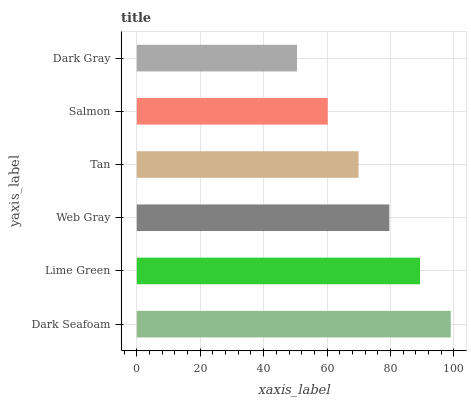Is Dark Gray the minimum?
Answer yes or no. Yes. Is Dark Seafoam the maximum?
Answer yes or no. Yes. Is Lime Green the minimum?
Answer yes or no. No. Is Lime Green the maximum?
Answer yes or no. No. Is Dark Seafoam greater than Lime Green?
Answer yes or no. Yes. Is Lime Green less than Dark Seafoam?
Answer yes or no. Yes. Is Lime Green greater than Dark Seafoam?
Answer yes or no. No. Is Dark Seafoam less than Lime Green?
Answer yes or no. No. Is Web Gray the high median?
Answer yes or no. Yes. Is Tan the low median?
Answer yes or no. Yes. Is Lime Green the high median?
Answer yes or no. No. Is Salmon the low median?
Answer yes or no. No. 